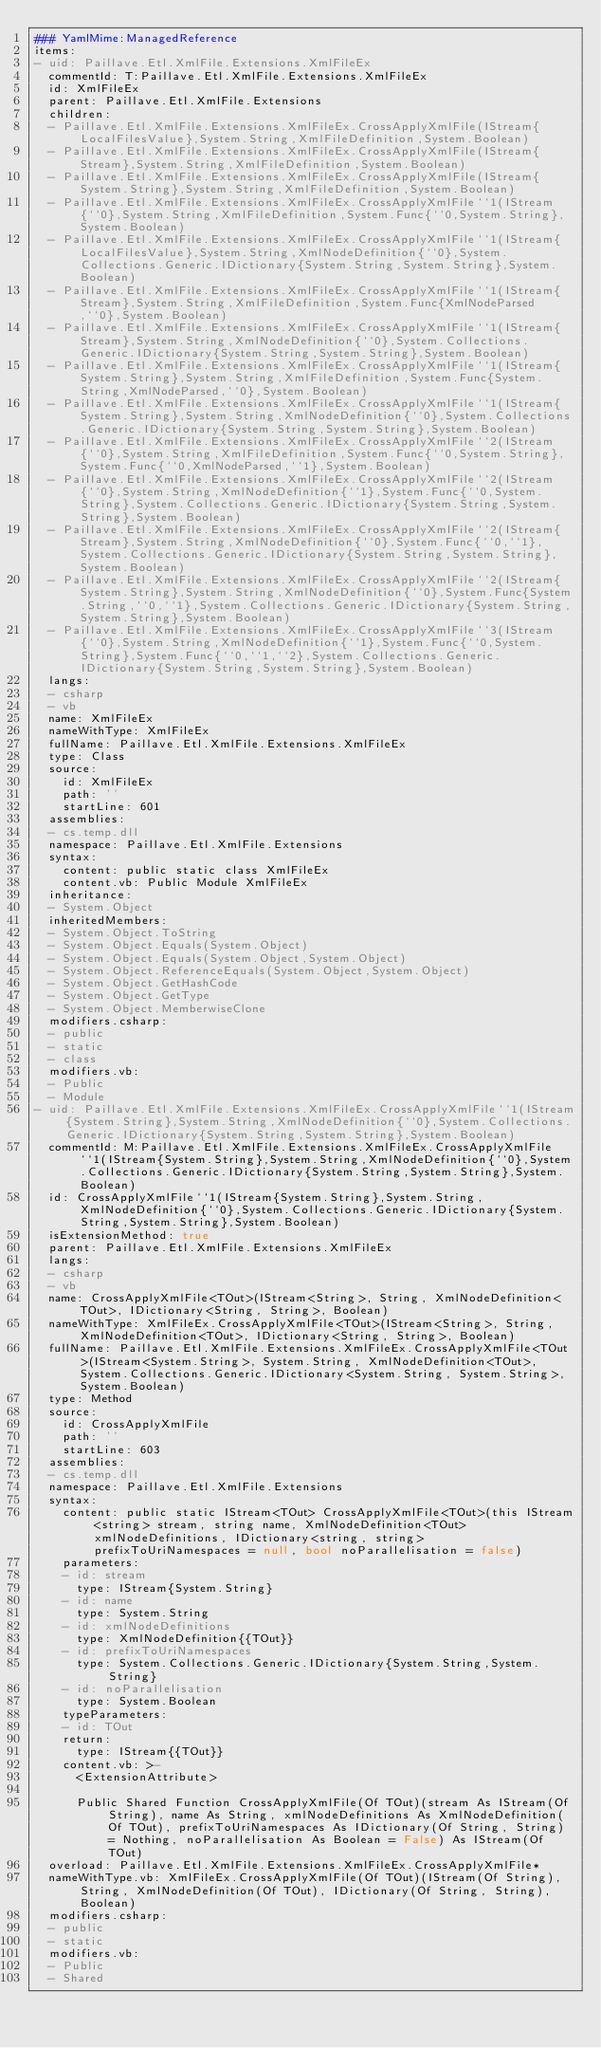<code> <loc_0><loc_0><loc_500><loc_500><_YAML_>### YamlMime:ManagedReference
items:
- uid: Paillave.Etl.XmlFile.Extensions.XmlFileEx
  commentId: T:Paillave.Etl.XmlFile.Extensions.XmlFileEx
  id: XmlFileEx
  parent: Paillave.Etl.XmlFile.Extensions
  children:
  - Paillave.Etl.XmlFile.Extensions.XmlFileEx.CrossApplyXmlFile(IStream{LocalFilesValue},System.String,XmlFileDefinition,System.Boolean)
  - Paillave.Etl.XmlFile.Extensions.XmlFileEx.CrossApplyXmlFile(IStream{Stream},System.String,XmlFileDefinition,System.Boolean)
  - Paillave.Etl.XmlFile.Extensions.XmlFileEx.CrossApplyXmlFile(IStream{System.String},System.String,XmlFileDefinition,System.Boolean)
  - Paillave.Etl.XmlFile.Extensions.XmlFileEx.CrossApplyXmlFile``1(IStream{``0},System.String,XmlFileDefinition,System.Func{``0,System.String},System.Boolean)
  - Paillave.Etl.XmlFile.Extensions.XmlFileEx.CrossApplyXmlFile``1(IStream{LocalFilesValue},System.String,XmlNodeDefinition{``0},System.Collections.Generic.IDictionary{System.String,System.String},System.Boolean)
  - Paillave.Etl.XmlFile.Extensions.XmlFileEx.CrossApplyXmlFile``1(IStream{Stream},System.String,XmlFileDefinition,System.Func{XmlNodeParsed,``0},System.Boolean)
  - Paillave.Etl.XmlFile.Extensions.XmlFileEx.CrossApplyXmlFile``1(IStream{Stream},System.String,XmlNodeDefinition{``0},System.Collections.Generic.IDictionary{System.String,System.String},System.Boolean)
  - Paillave.Etl.XmlFile.Extensions.XmlFileEx.CrossApplyXmlFile``1(IStream{System.String},System.String,XmlFileDefinition,System.Func{System.String,XmlNodeParsed,``0},System.Boolean)
  - Paillave.Etl.XmlFile.Extensions.XmlFileEx.CrossApplyXmlFile``1(IStream{System.String},System.String,XmlNodeDefinition{``0},System.Collections.Generic.IDictionary{System.String,System.String},System.Boolean)
  - Paillave.Etl.XmlFile.Extensions.XmlFileEx.CrossApplyXmlFile``2(IStream{``0},System.String,XmlFileDefinition,System.Func{``0,System.String},System.Func{``0,XmlNodeParsed,``1},System.Boolean)
  - Paillave.Etl.XmlFile.Extensions.XmlFileEx.CrossApplyXmlFile``2(IStream{``0},System.String,XmlNodeDefinition{``1},System.Func{``0,System.String},System.Collections.Generic.IDictionary{System.String,System.String},System.Boolean)
  - Paillave.Etl.XmlFile.Extensions.XmlFileEx.CrossApplyXmlFile``2(IStream{Stream},System.String,XmlNodeDefinition{``0},System.Func{``0,``1},System.Collections.Generic.IDictionary{System.String,System.String},System.Boolean)
  - Paillave.Etl.XmlFile.Extensions.XmlFileEx.CrossApplyXmlFile``2(IStream{System.String},System.String,XmlNodeDefinition{``0},System.Func{System.String,``0,``1},System.Collections.Generic.IDictionary{System.String,System.String},System.Boolean)
  - Paillave.Etl.XmlFile.Extensions.XmlFileEx.CrossApplyXmlFile``3(IStream{``0},System.String,XmlNodeDefinition{``1},System.Func{``0,System.String},System.Func{``0,``1,``2},System.Collections.Generic.IDictionary{System.String,System.String},System.Boolean)
  langs:
  - csharp
  - vb
  name: XmlFileEx
  nameWithType: XmlFileEx
  fullName: Paillave.Etl.XmlFile.Extensions.XmlFileEx
  type: Class
  source:
    id: XmlFileEx
    path: ''
    startLine: 601
  assemblies:
  - cs.temp.dll
  namespace: Paillave.Etl.XmlFile.Extensions
  syntax:
    content: public static class XmlFileEx
    content.vb: Public Module XmlFileEx
  inheritance:
  - System.Object
  inheritedMembers:
  - System.Object.ToString
  - System.Object.Equals(System.Object)
  - System.Object.Equals(System.Object,System.Object)
  - System.Object.ReferenceEquals(System.Object,System.Object)
  - System.Object.GetHashCode
  - System.Object.GetType
  - System.Object.MemberwiseClone
  modifiers.csharp:
  - public
  - static
  - class
  modifiers.vb:
  - Public
  - Module
- uid: Paillave.Etl.XmlFile.Extensions.XmlFileEx.CrossApplyXmlFile``1(IStream{System.String},System.String,XmlNodeDefinition{``0},System.Collections.Generic.IDictionary{System.String,System.String},System.Boolean)
  commentId: M:Paillave.Etl.XmlFile.Extensions.XmlFileEx.CrossApplyXmlFile``1(IStream{System.String},System.String,XmlNodeDefinition{``0},System.Collections.Generic.IDictionary{System.String,System.String},System.Boolean)
  id: CrossApplyXmlFile``1(IStream{System.String},System.String,XmlNodeDefinition{``0},System.Collections.Generic.IDictionary{System.String,System.String},System.Boolean)
  isExtensionMethod: true
  parent: Paillave.Etl.XmlFile.Extensions.XmlFileEx
  langs:
  - csharp
  - vb
  name: CrossApplyXmlFile<TOut>(IStream<String>, String, XmlNodeDefinition<TOut>, IDictionary<String, String>, Boolean)
  nameWithType: XmlFileEx.CrossApplyXmlFile<TOut>(IStream<String>, String, XmlNodeDefinition<TOut>, IDictionary<String, String>, Boolean)
  fullName: Paillave.Etl.XmlFile.Extensions.XmlFileEx.CrossApplyXmlFile<TOut>(IStream<System.String>, System.String, XmlNodeDefinition<TOut>, System.Collections.Generic.IDictionary<System.String, System.String>, System.Boolean)
  type: Method
  source:
    id: CrossApplyXmlFile
    path: ''
    startLine: 603
  assemblies:
  - cs.temp.dll
  namespace: Paillave.Etl.XmlFile.Extensions
  syntax:
    content: public static IStream<TOut> CrossApplyXmlFile<TOut>(this IStream<string> stream, string name, XmlNodeDefinition<TOut> xmlNodeDefinitions, IDictionary<string, string> prefixToUriNamespaces = null, bool noParallelisation = false)
    parameters:
    - id: stream
      type: IStream{System.String}
    - id: name
      type: System.String
    - id: xmlNodeDefinitions
      type: XmlNodeDefinition{{TOut}}
    - id: prefixToUriNamespaces
      type: System.Collections.Generic.IDictionary{System.String,System.String}
    - id: noParallelisation
      type: System.Boolean
    typeParameters:
    - id: TOut
    return:
      type: IStream{{TOut}}
    content.vb: >-
      <ExtensionAttribute>

      Public Shared Function CrossApplyXmlFile(Of TOut)(stream As IStream(Of String), name As String, xmlNodeDefinitions As XmlNodeDefinition(Of TOut), prefixToUriNamespaces As IDictionary(Of String, String) = Nothing, noParallelisation As Boolean = False) As IStream(Of TOut)
  overload: Paillave.Etl.XmlFile.Extensions.XmlFileEx.CrossApplyXmlFile*
  nameWithType.vb: XmlFileEx.CrossApplyXmlFile(Of TOut)(IStream(Of String), String, XmlNodeDefinition(Of TOut), IDictionary(Of String, String), Boolean)
  modifiers.csharp:
  - public
  - static
  modifiers.vb:
  - Public
  - Shared</code> 